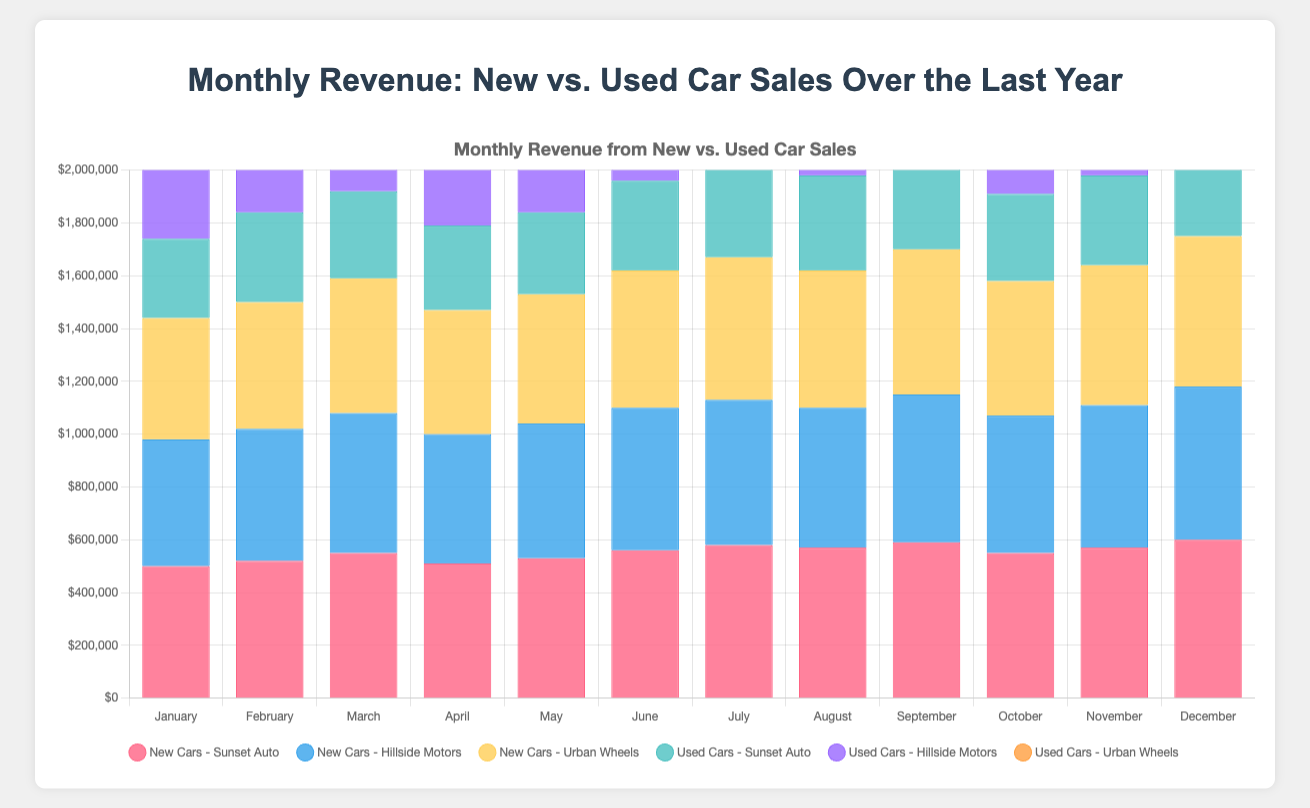What's the total revenue for new car sales at Sunset Auto in the first quarter (January - March)? The monthly revenues for Sunset Auto in the first quarter are $500,000, $520,000, and $550,000. Adding these up gives $1,570,000.
Answer: $1,570,000 Which dealership had the highest revenue from used car sales in December? In December, the revenues from used car sales are $380,000 (Sunset Auto), $370,000 (Hillside Motors), and $360,000 (Urban Wheels). Sunset Auto had the highest revenue.
Answer: Sunset Auto Did Urban Wheels have higher revenue from new car sales or used car sales in July? In July, Urban Wheels had a revenue of $540,000 from new car sales and $340,000 from used car sales. New car sales revenue was higher.
Answer: New car sales Compare the new car sales revenue in November among all three dealerships. Rank them. In November, the new car sales revenues were $570,000 (Sunset Auto), $540,000 (Hillside Motors), and $530,000 (Urban Wheels). Ranking from highest to lowest: 1. Sunset Auto 2. Hillside Motors 3. Urban Wheels
Answer: Sunset Auto > Hillside Motors > Urban Wheels By how much did the total monthly revenue for Hillside Motors from used car sales increase from January to December? Hillside Motors had $290,000 in January and $370,000 in December from used car sales. The increase is $370,000 - $290,000 = $80,000.
Answer: $80,000 What is the average monthly revenue from new car sales in August for all three dealerships combined? In August, the revenues from new car sales were $570,000 (Sunset Auto), $530,000 (Hillside Motors), and $520,000 (Urban Wheels). The total is $1,620,000, and the average is $1,620,000 / 3 = $540,000.
Answer: $540,000 Which month had the lowest combined revenue from used car sales across all dealerships? Summing up the used car sales revenues for each month, March had the lowest combined revenue: Sunset Auto ($330,000) + Hillside Motors ($320,000) + Urban Wheels ($290,000) = $940,000.
Answer: March In which month did Urban Wheels have the smallest gap between new car and used car sales revenue? Checking the differences month by month, the smallest gap for Urban Wheels is in February: New Car ($480,000) - Used Car ($300,000) = $180,000.
Answer: February What is the total revenue generated by new car sales across all dealerships for the entire year? Summing up the new car sales across all months and dealerships: Sunset Auto ($6,690,000), Hillside Motors ($6,180,000), Urban Wheels ($6,100,000). The total is $6,690,000 + $6,180,000 + $6,100,000 = $18,970,000.
Answer: $18,970,000 